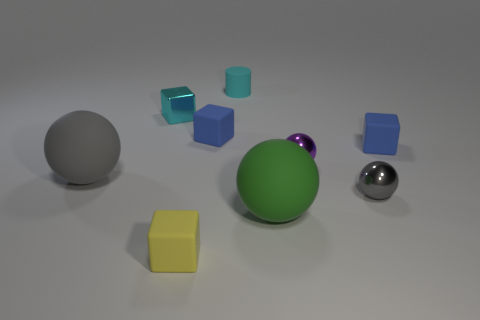Subtract 1 cubes. How many cubes are left? 3 Add 1 small cyan objects. How many objects exist? 10 Subtract all cylinders. How many objects are left? 8 Subtract 0 brown balls. How many objects are left? 9 Subtract all blue objects. Subtract all big green things. How many objects are left? 6 Add 5 green balls. How many green balls are left? 6 Add 9 large matte cubes. How many large matte cubes exist? 9 